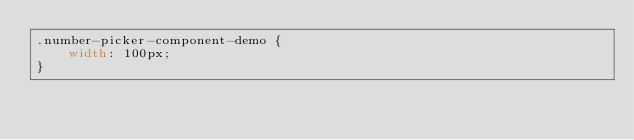Convert code to text. <code><loc_0><loc_0><loc_500><loc_500><_CSS_>.number-picker-component-demo {
    width: 100px;
}
</code> 